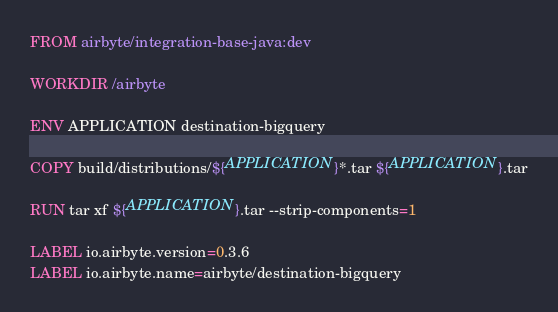Convert code to text. <code><loc_0><loc_0><loc_500><loc_500><_Dockerfile_>FROM airbyte/integration-base-java:dev

WORKDIR /airbyte

ENV APPLICATION destination-bigquery

COPY build/distributions/${APPLICATION}*.tar ${APPLICATION}.tar

RUN tar xf ${APPLICATION}.tar --strip-components=1

LABEL io.airbyte.version=0.3.6
LABEL io.airbyte.name=airbyte/destination-bigquery
</code> 